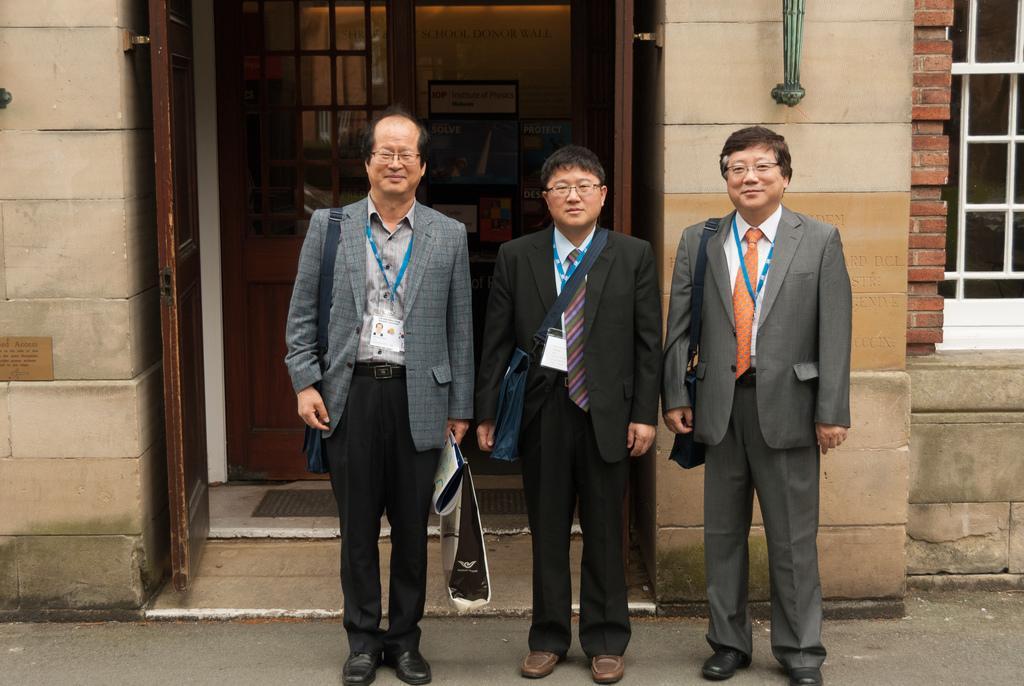Can you describe this image briefly? In this image I can see three people standing and wearing the different color dresses. I can see these people are wearing the specs and also the bags. In the background I can see the building with window and some boards inside the building. 